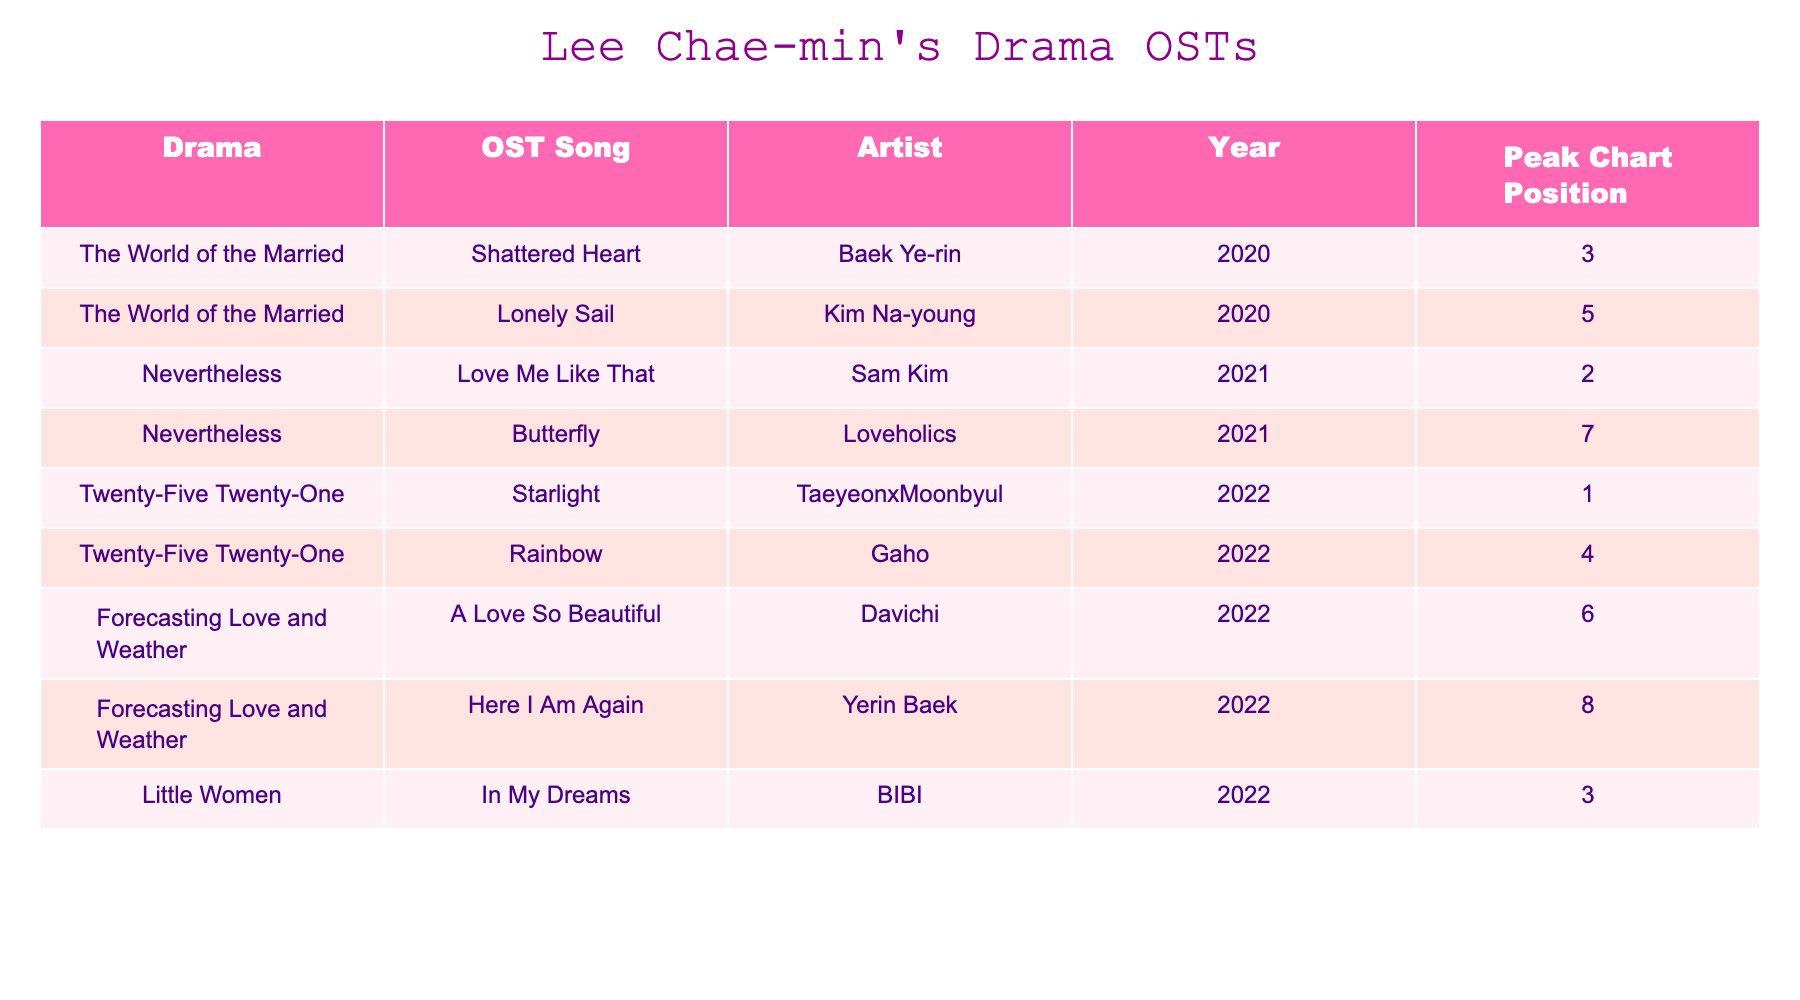What is the title of the OST song from "Twenty-Five Twenty-One" that reached the highest chart position? The highest chart position in the table for "Twenty-Five Twenty-One" is 1, which corresponds to the song "Starlight."
Answer: Starlight Who performed the OST song "A Love So Beautiful"? By checking the table, "A Love So Beautiful" is performed by the artist Davichi.
Answer: Davichi Which drama has the OST song "Shattered Heart"? The drama corresponding to the OST song "Shattered Heart" in the table is "The World of the Married."
Answer: The World of the Married What year was "Rainbow" released? Looking at the table, "Rainbow" was released in the year 2022.
Answer: 2022 Which OST song from "Nevertheless" has a higher peak chart position: "Love Me Like That" or "Butterfly"? By comparing the peak chart positions in the table, "Love Me Like That" peaked at 2, while "Butterfly" peaked at 7; thus, "Love Me Like That" has the higher position.
Answer: Love Me Like That How many OST songs from "Forecasting Love and Weather" reached the top 10 of the charts? There are two songs from "Forecasting Love and Weather" in the top 10: "A Love So Beautiful" (6) and "Here I Am Again" (8), so the count is 2.
Answer: 2 Which artist has the most OST songs listed in this table? By examining the table, each artist is listed once except for Baek Ye-rin, who has one song, and the others are unique, thus indicating multiple single appearances.
Answer: None What is the average peak chart position of the OSTs listed in the table? Calculating the average, we sum the peak chart positions: (3 + 5 + 2 + 7 + 1 + 4 + 6 + 8 + 3) = 39. There are 9 songs so the average is 39/9 = 4.33.
Answer: 4.33 Is "Here I Am Again" from "Little Women"? According to the table, "Here I Am Again" comes from "Forecasting Love and Weather," so the answer is no.
Answer: No Which song from "Little Women" has a peak chart position of 3? By looking at the table, the song "In My Dreams" from "Little Women" has a peak chart position of 3.
Answer: In My Dreams 